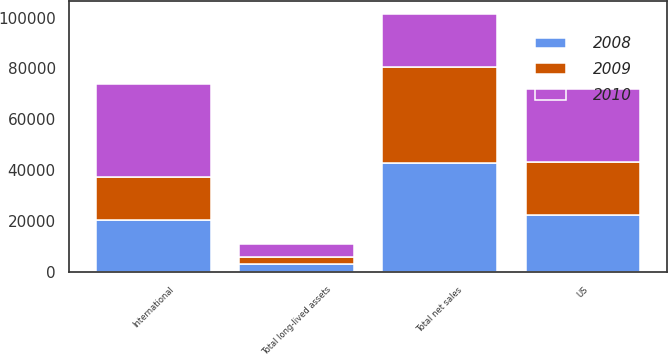Convert chart to OTSL. <chart><loc_0><loc_0><loc_500><loc_500><stacked_bar_chart><ecel><fcel>US<fcel>International<fcel>Total net sales<fcel>Total long-lived assets<nl><fcel>2010<fcel>28633<fcel>36592<fcel>20893<fcel>5002<nl><fcel>2008<fcel>22325<fcel>20580<fcel>42905<fcel>3193<nl><fcel>2009<fcel>20893<fcel>16598<fcel>37491<fcel>2679<nl></chart> 